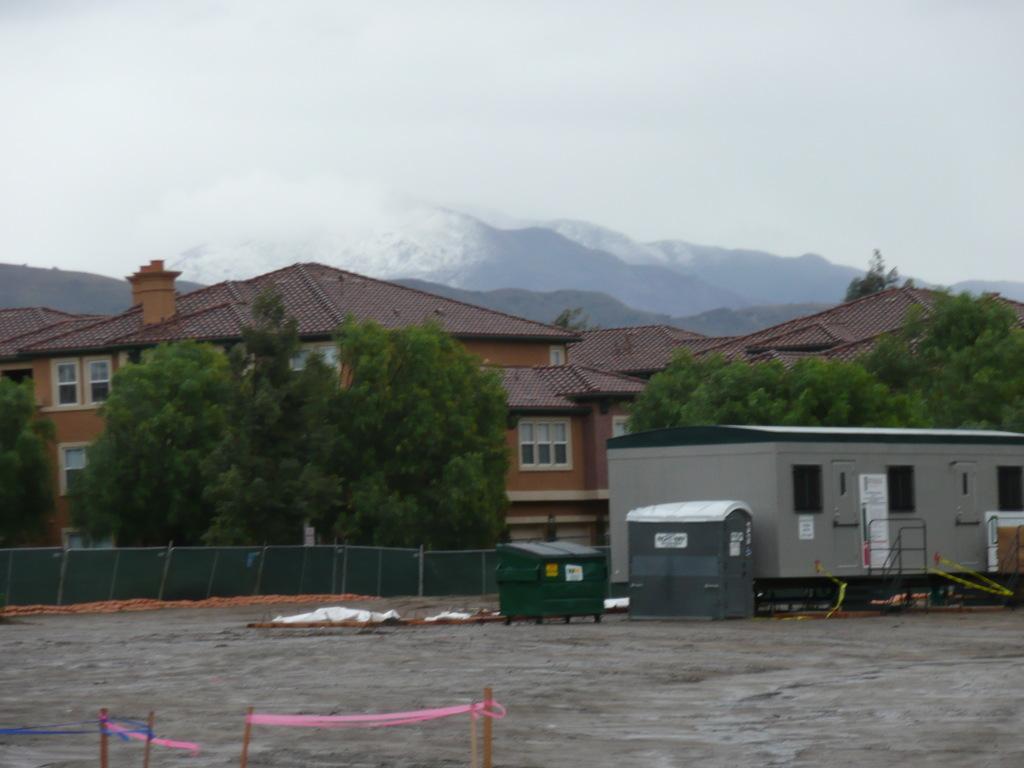In one or two sentences, can you explain what this image depicts? In this picture I can see buildings, trees and the sky. Here I can see a fence and some other objects on the ground. In the background, I can see mountains. 